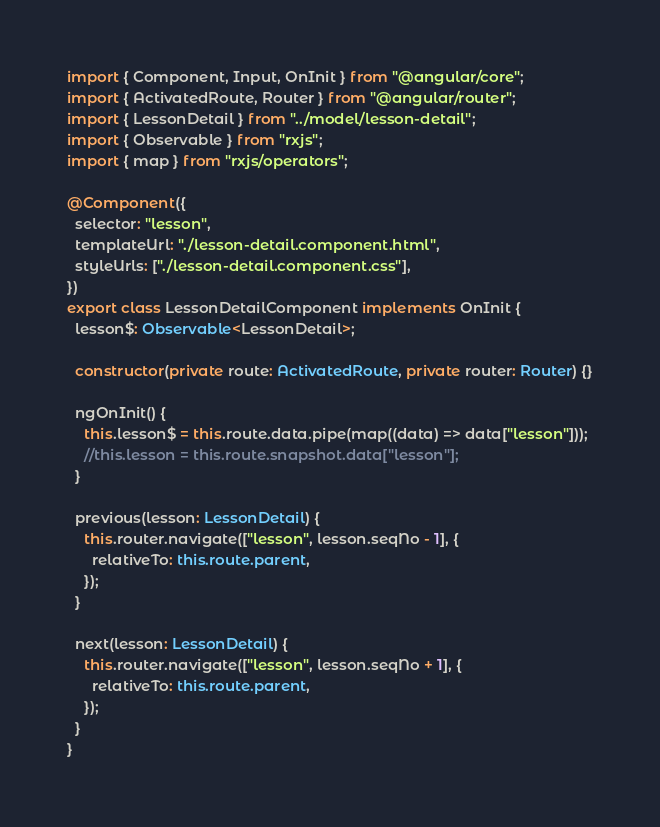Convert code to text. <code><loc_0><loc_0><loc_500><loc_500><_TypeScript_>import { Component, Input, OnInit } from "@angular/core";
import { ActivatedRoute, Router } from "@angular/router";
import { LessonDetail } from "../model/lesson-detail";
import { Observable } from "rxjs";
import { map } from "rxjs/operators";

@Component({
  selector: "lesson",
  templateUrl: "./lesson-detail.component.html",
  styleUrls: ["./lesson-detail.component.css"],
})
export class LessonDetailComponent implements OnInit {
  lesson$: Observable<LessonDetail>;

  constructor(private route: ActivatedRoute, private router: Router) {}

  ngOnInit() {
    this.lesson$ = this.route.data.pipe(map((data) => data["lesson"]));
    //this.lesson = this.route.snapshot.data["lesson"];
  }

  previous(lesson: LessonDetail) {
    this.router.navigate(["lesson", lesson.seqNo - 1], {
      relativeTo: this.route.parent,
    });
  }

  next(lesson: LessonDetail) {
    this.router.navigate(["lesson", lesson.seqNo + 1], {
      relativeTo: this.route.parent,
    });
  }
}
</code> 